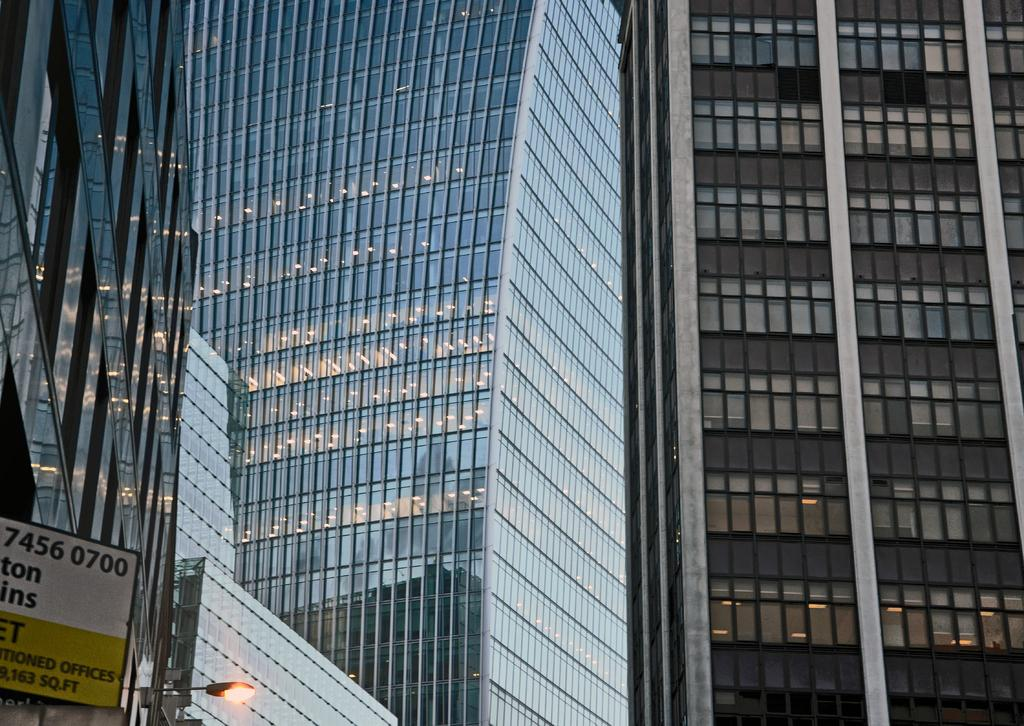What type of buildings are shown in the image? The buildings in the image have glass windows. Can you describe the lighting in the buildings? The buildings have lights inside them. What is located in the bottom left corner of the image? There is a street light and a board in the bottom left corner of the image. What type of appliance is being used by the wren in the image? There is no wren or appliance present in the image. 